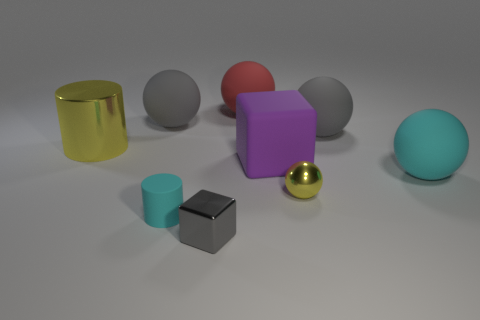Subtract all tiny spheres. How many spheres are left? 4 Subtract all yellow spheres. How many spheres are left? 4 Subtract 2 cylinders. How many cylinders are left? 0 Add 1 large yellow metal balls. How many objects exist? 10 Subtract all balls. How many objects are left? 4 Subtract all green cylinders. How many gray spheres are left? 2 Subtract all cyan cubes. Subtract all red spheres. How many cubes are left? 2 Subtract all cyan cylinders. Subtract all tiny balls. How many objects are left? 7 Add 2 gray cubes. How many gray cubes are left? 3 Add 8 small cyan rubber things. How many small cyan rubber things exist? 9 